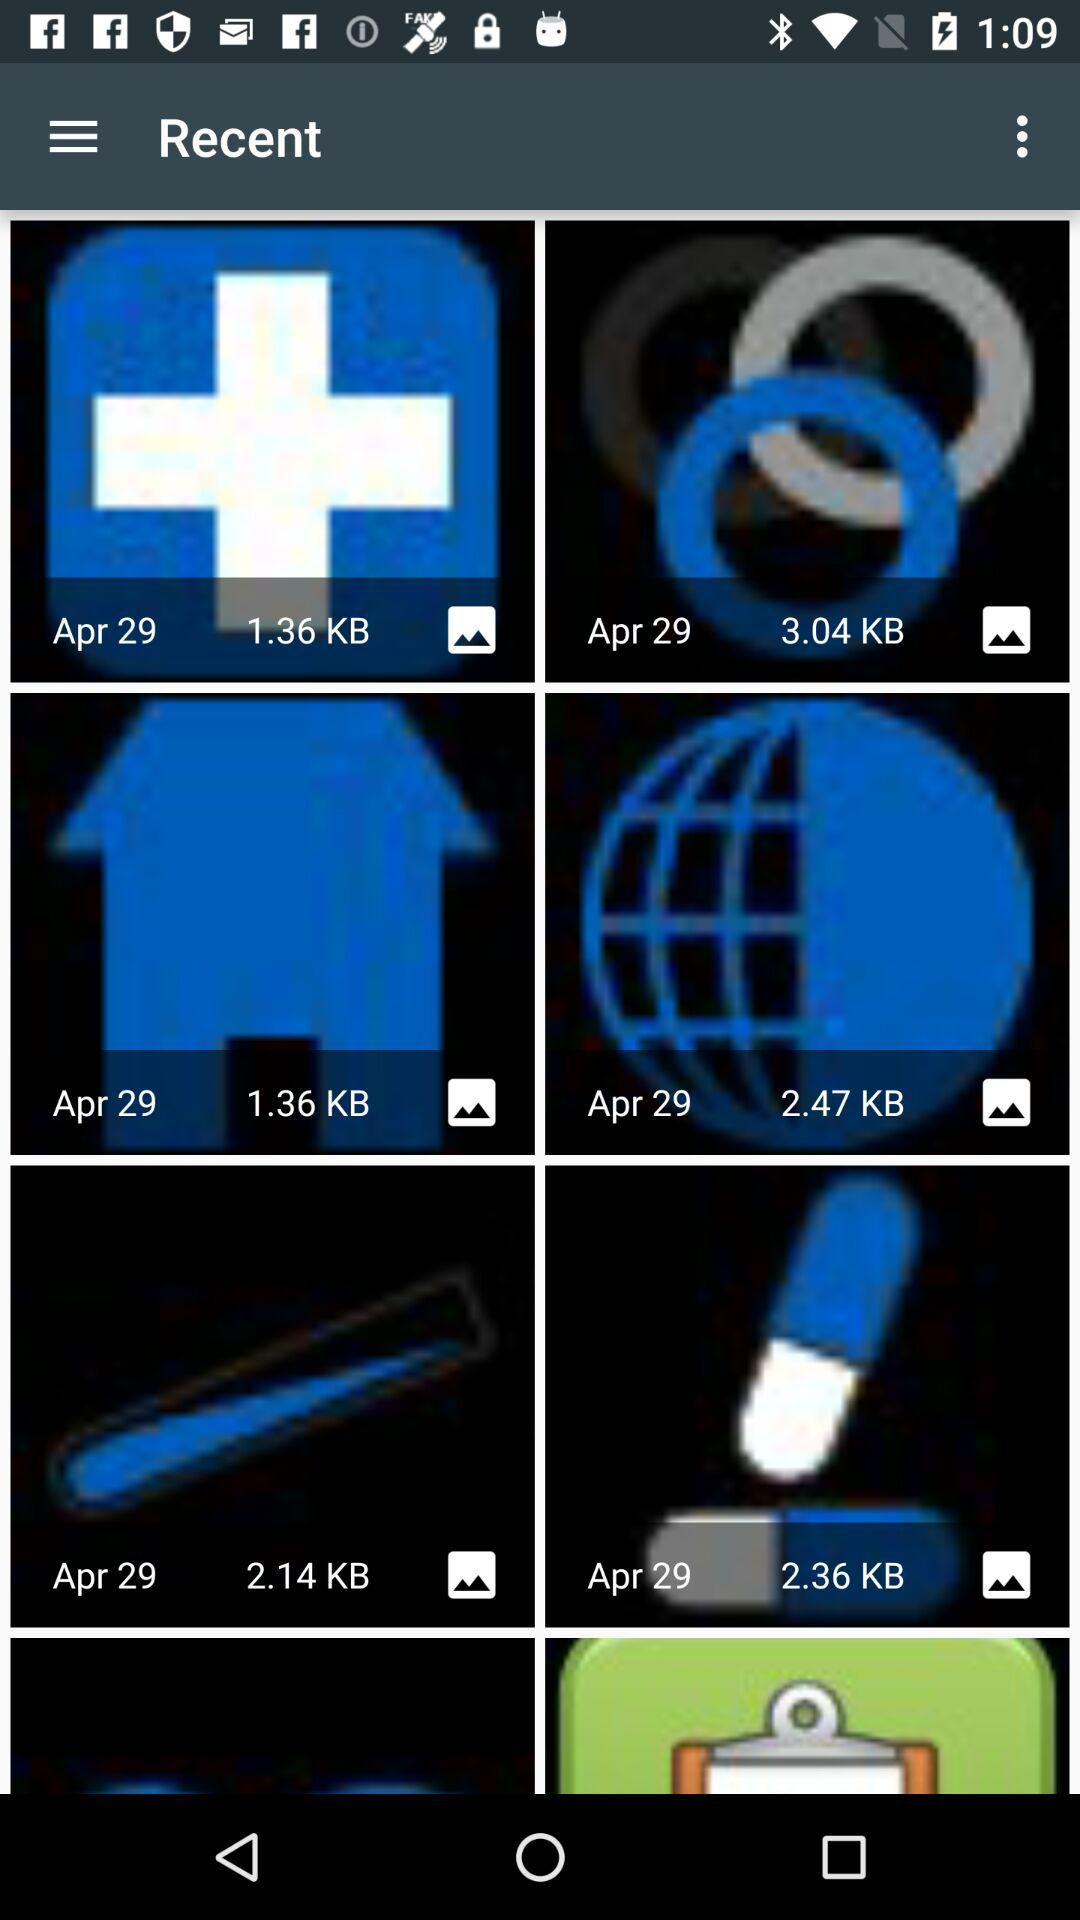What is the given date? The given date is April 29. 